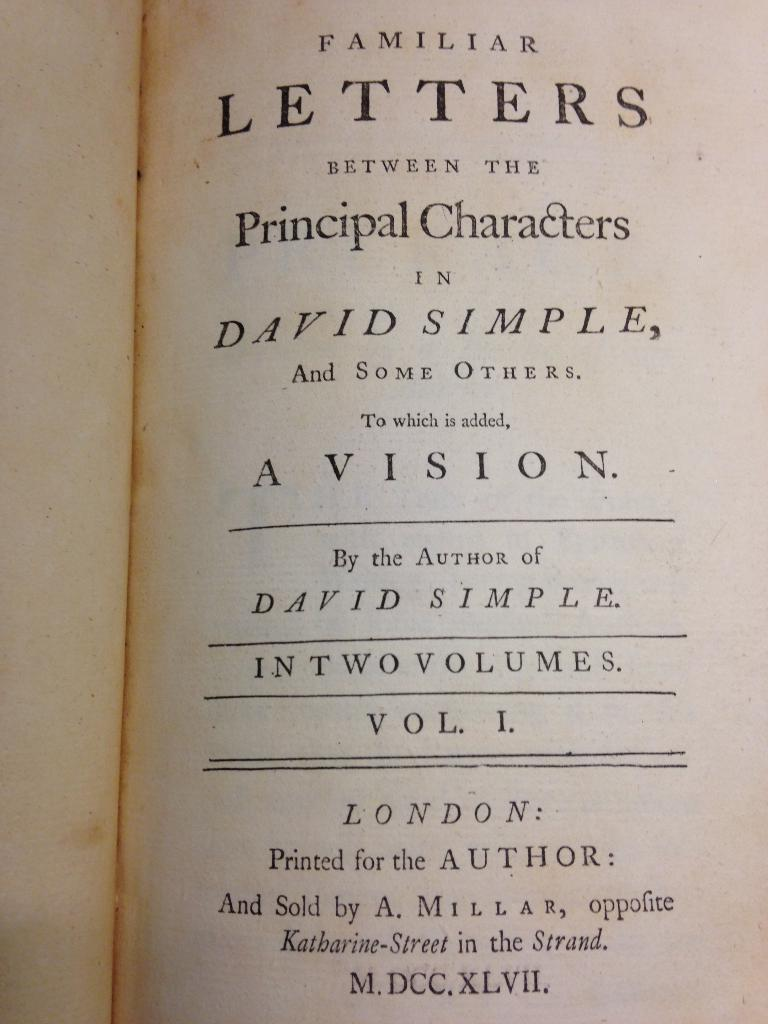<image>
Describe the image concisely. A title page to Familiar Letters between the Principal Characters in David Simple, volume 1. 